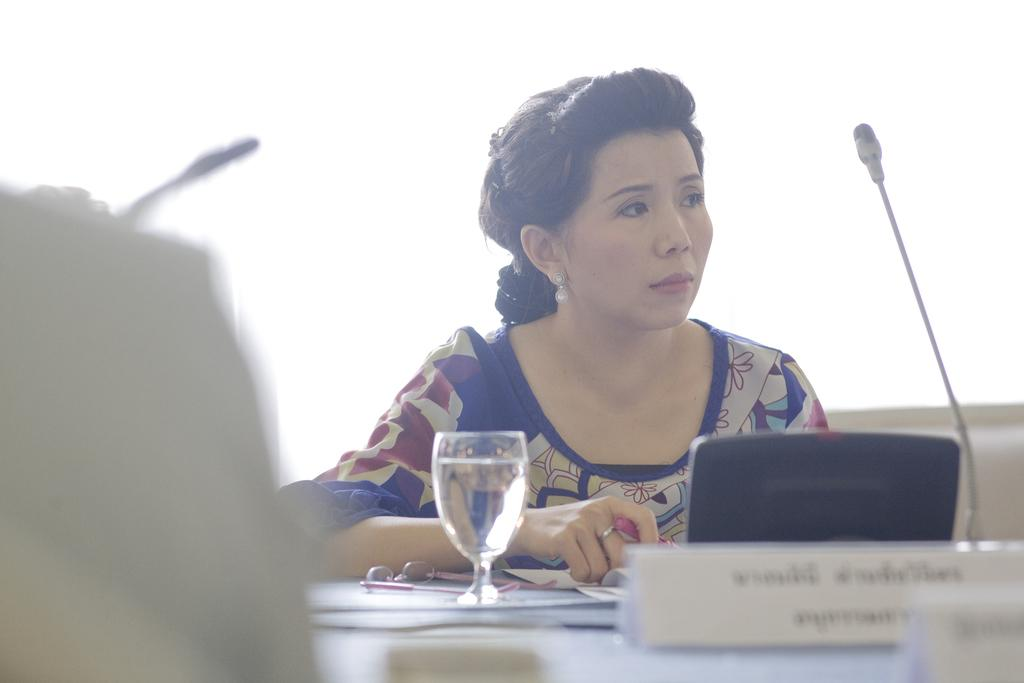Who is the main subject in the image? There is a woman in the image. What is the woman wearing? The woman is wearing a blue dress and earrings. What is the woman doing in the image? The woman is leaning on a table. What objects are on the table? There is a glass, a laptop, a board, and a microphone on the table. What type of boats can be seen in the image? There are no boats present in the image. What month is it in the image? The image does not provide any information about the month. 